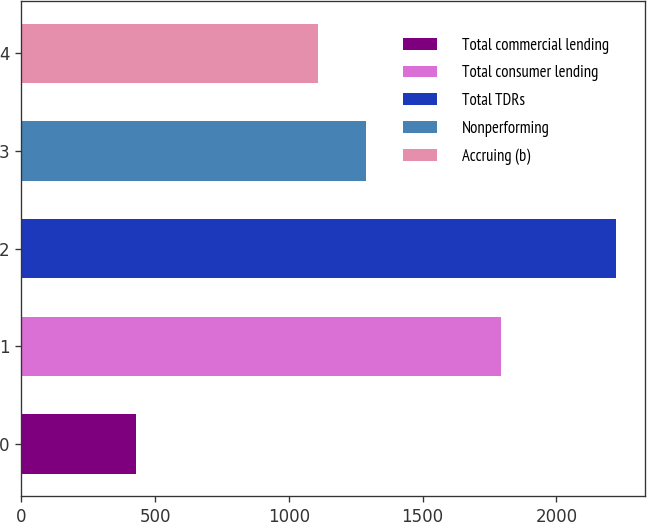Convert chart to OTSL. <chart><loc_0><loc_0><loc_500><loc_500><bar_chart><fcel>Total commercial lending<fcel>Total consumer lending<fcel>Total TDRs<fcel>Nonperforming<fcel>Accruing (b)<nl><fcel>428<fcel>1793<fcel>2221<fcel>1288.3<fcel>1109<nl></chart> 